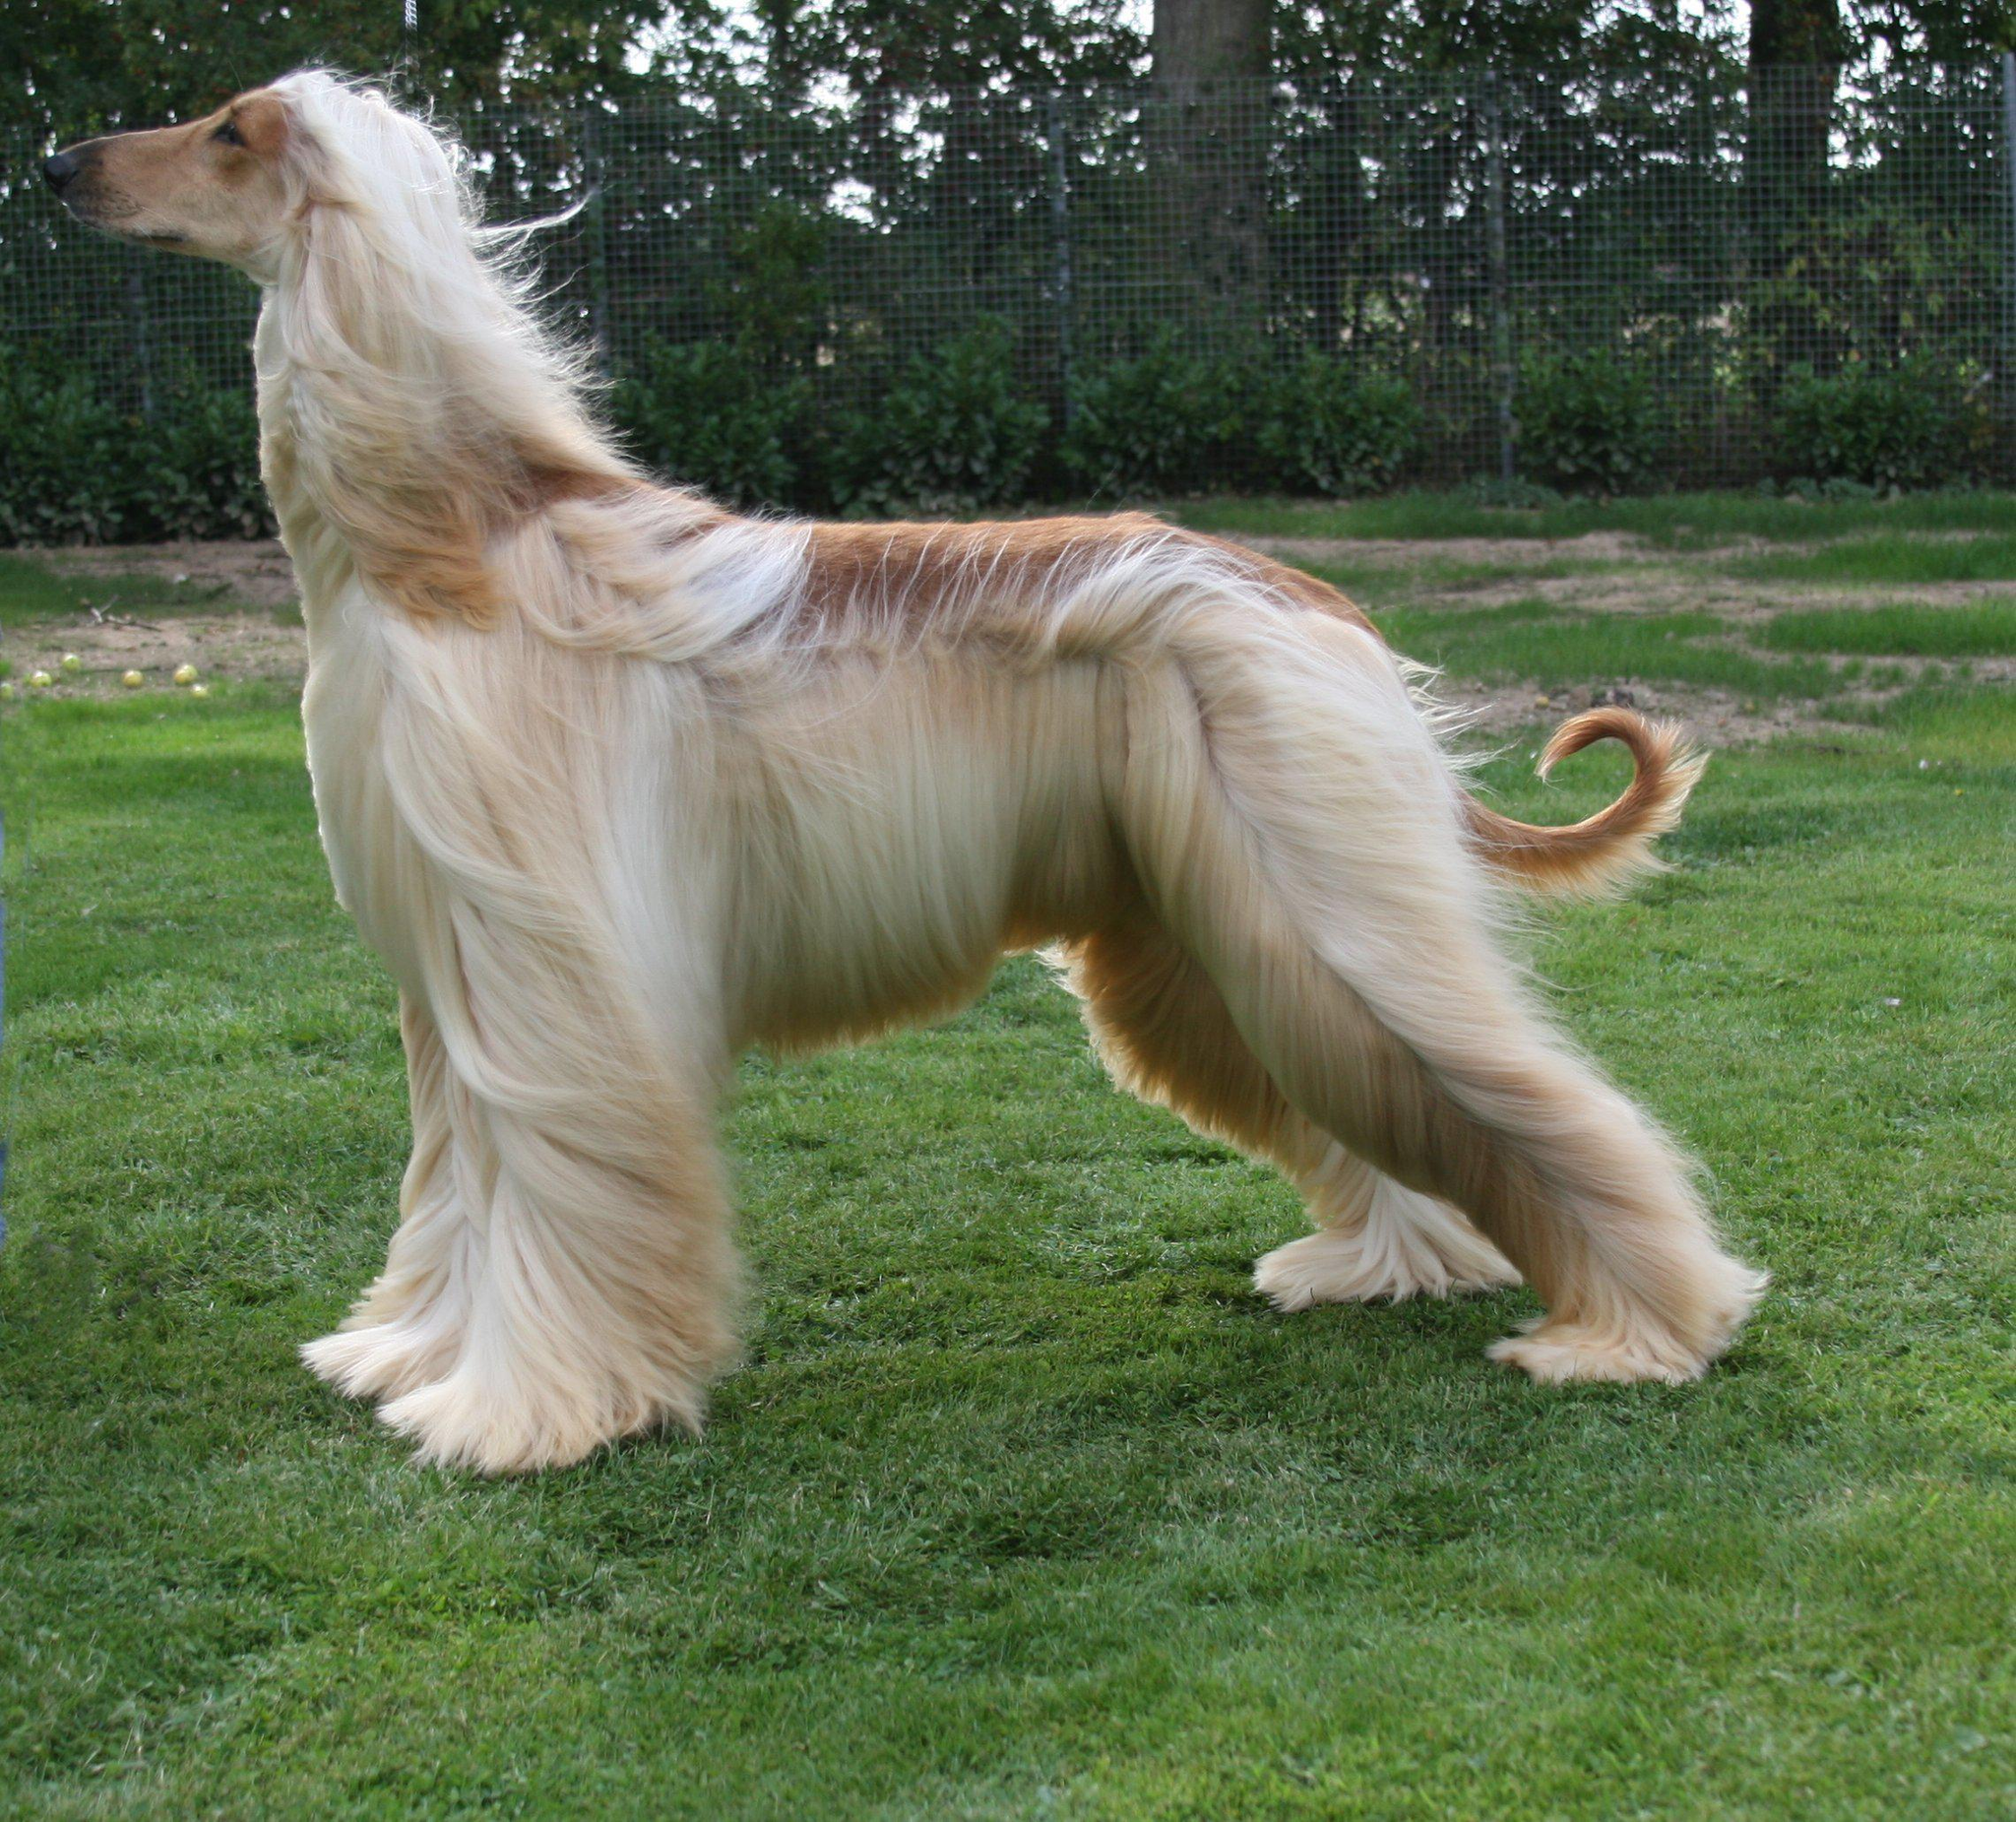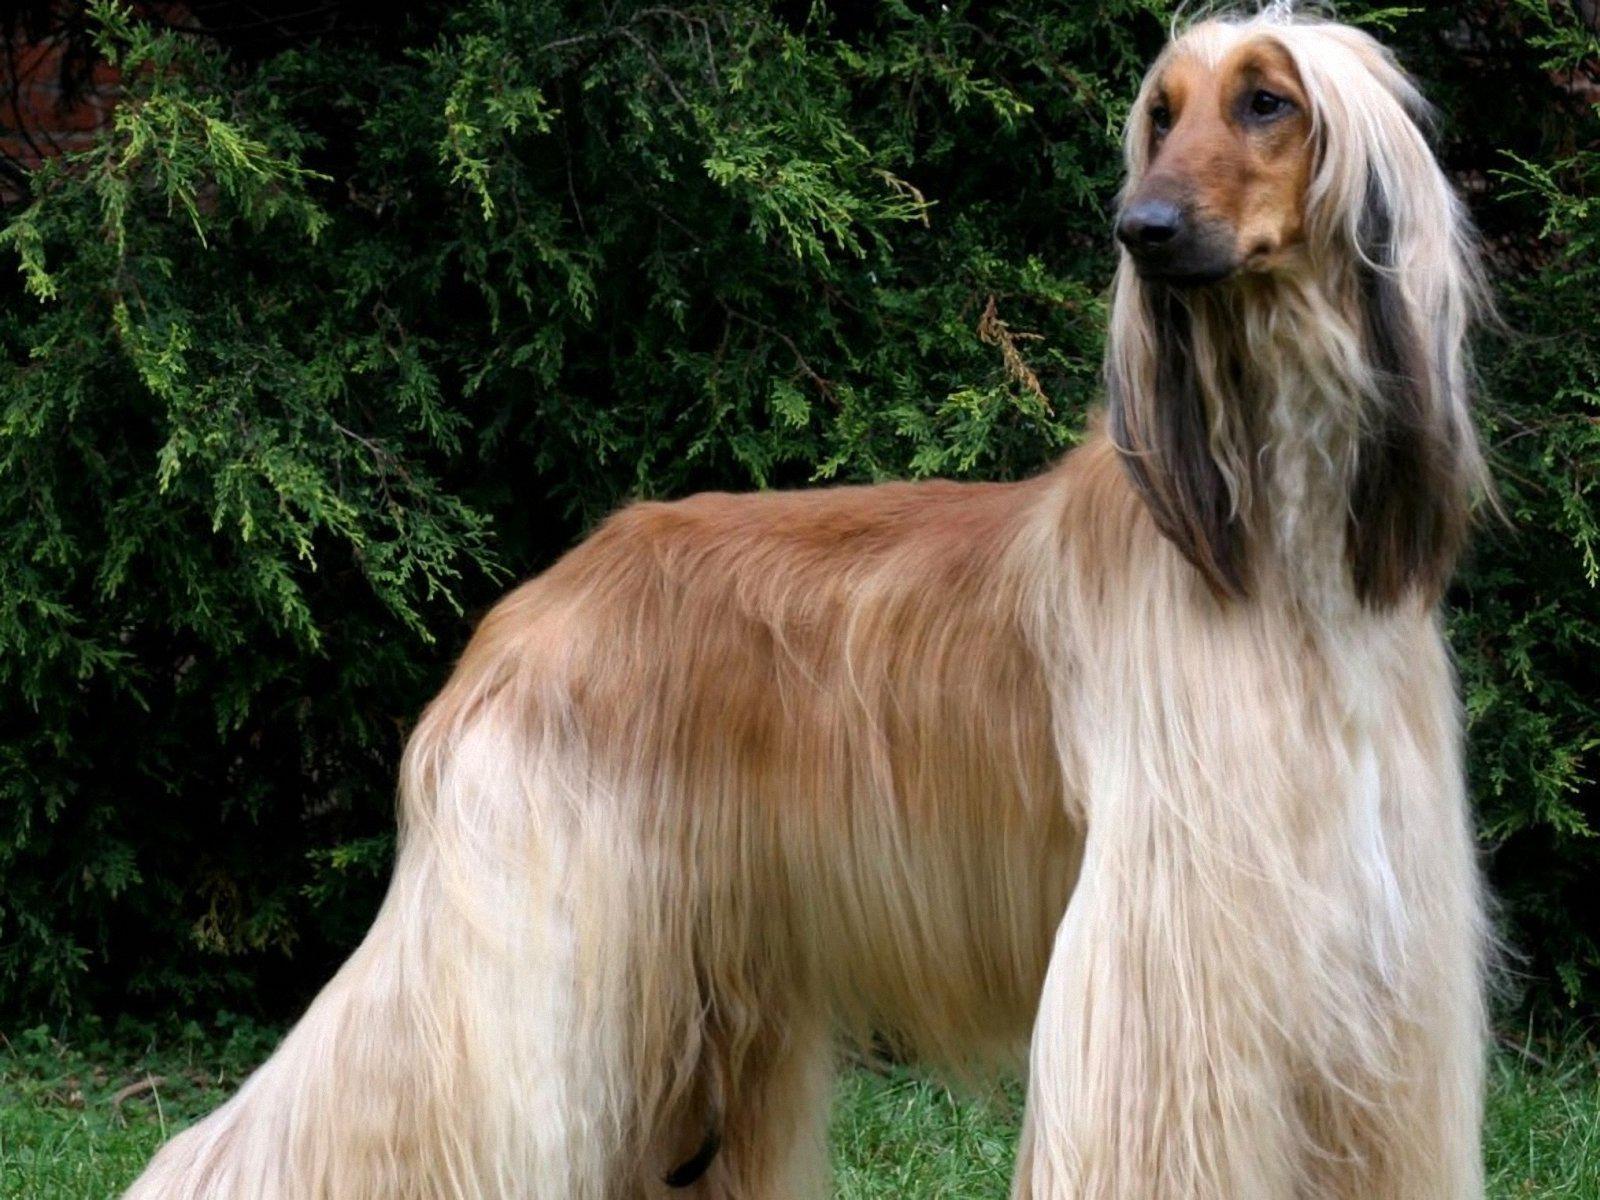The first image is the image on the left, the second image is the image on the right. Considering the images on both sides, is "At least one dog is sitting upright in the grass." valid? Answer yes or no. No. 